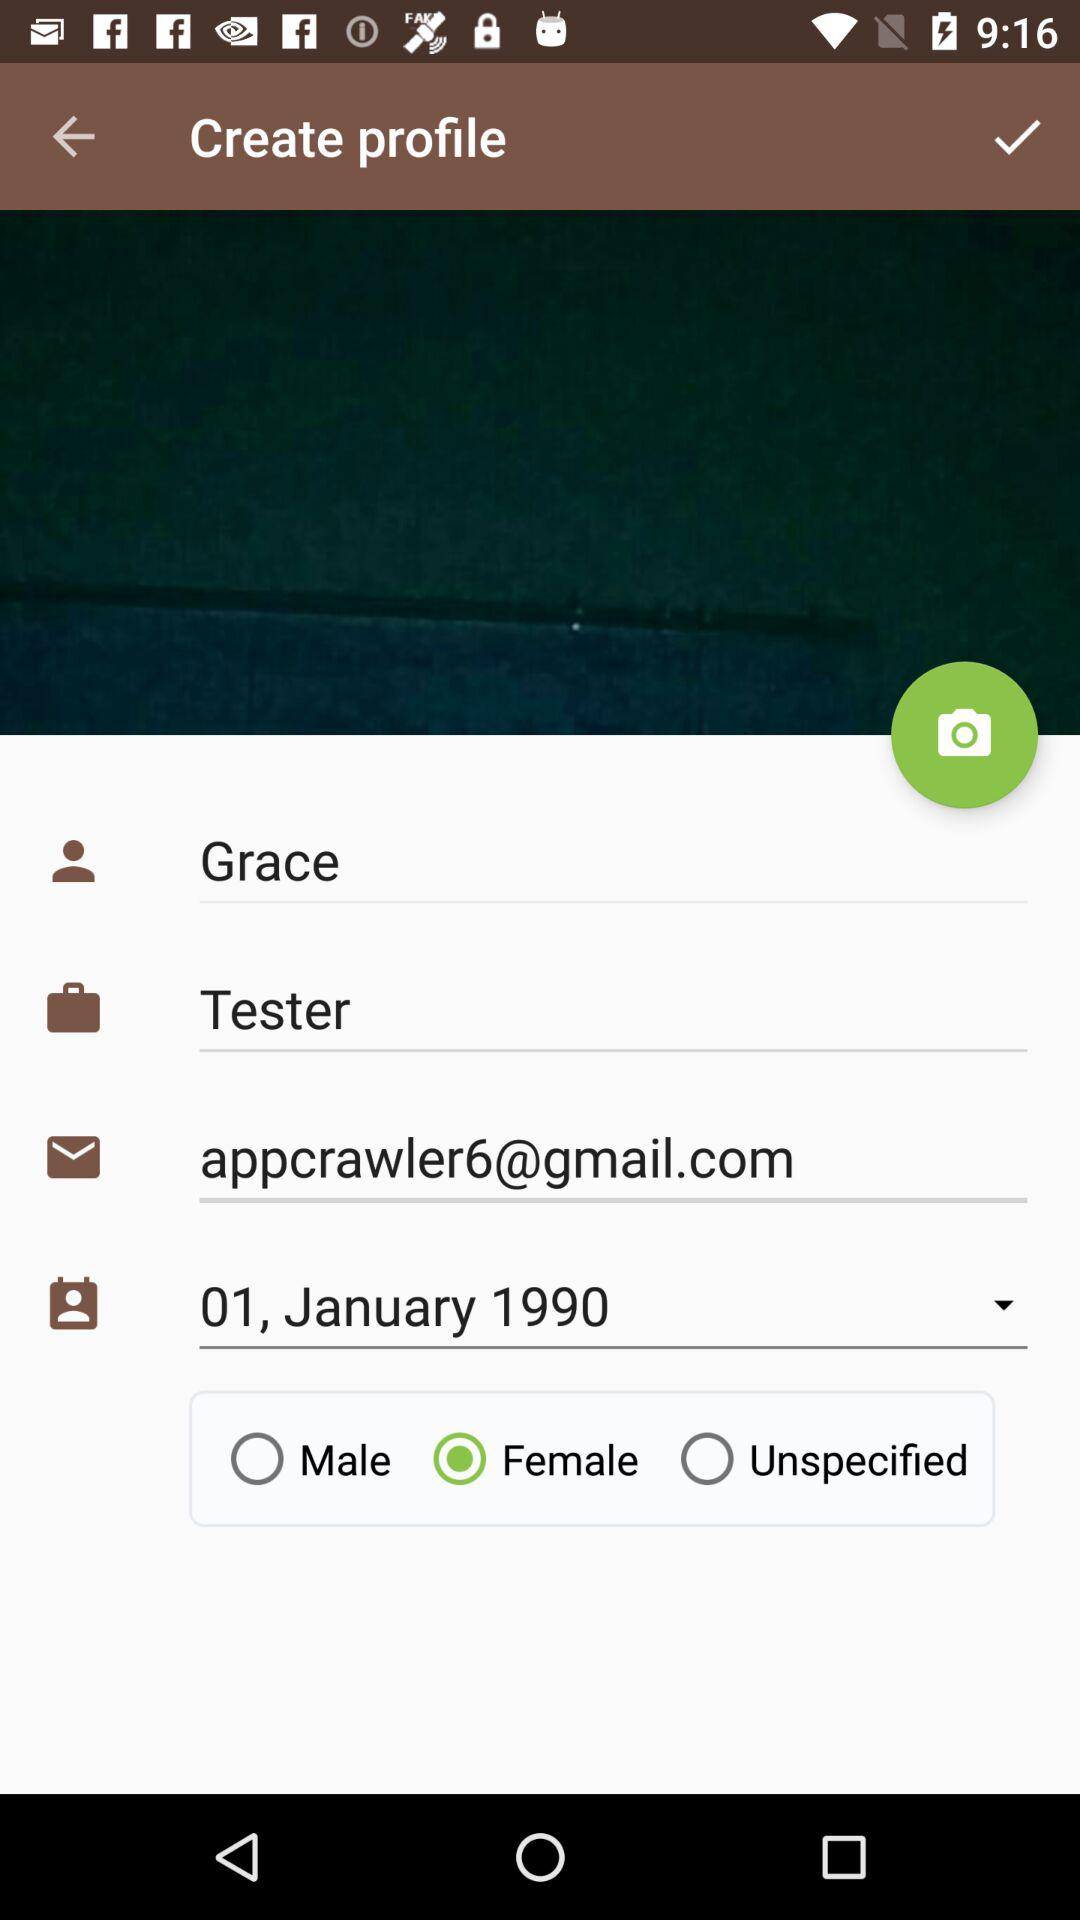What is the gender of the user? The gender of the user is female. 